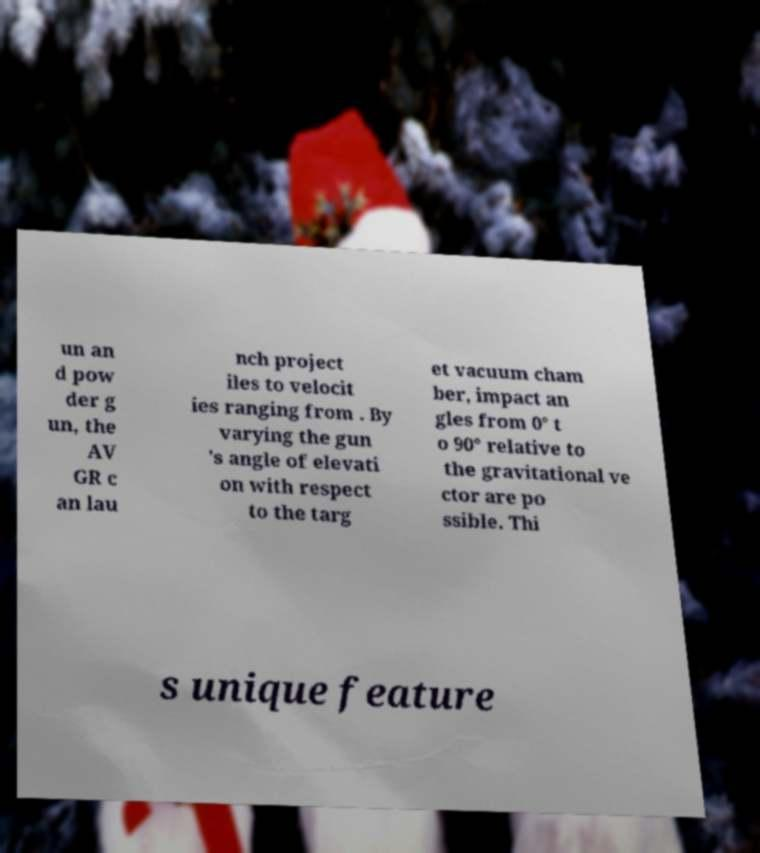Please identify and transcribe the text found in this image. un an d pow der g un, the AV GR c an lau nch project iles to velocit ies ranging from . By varying the gun 's angle of elevati on with respect to the targ et vacuum cham ber, impact an gles from 0° t o 90° relative to the gravitational ve ctor are po ssible. Thi s unique feature 